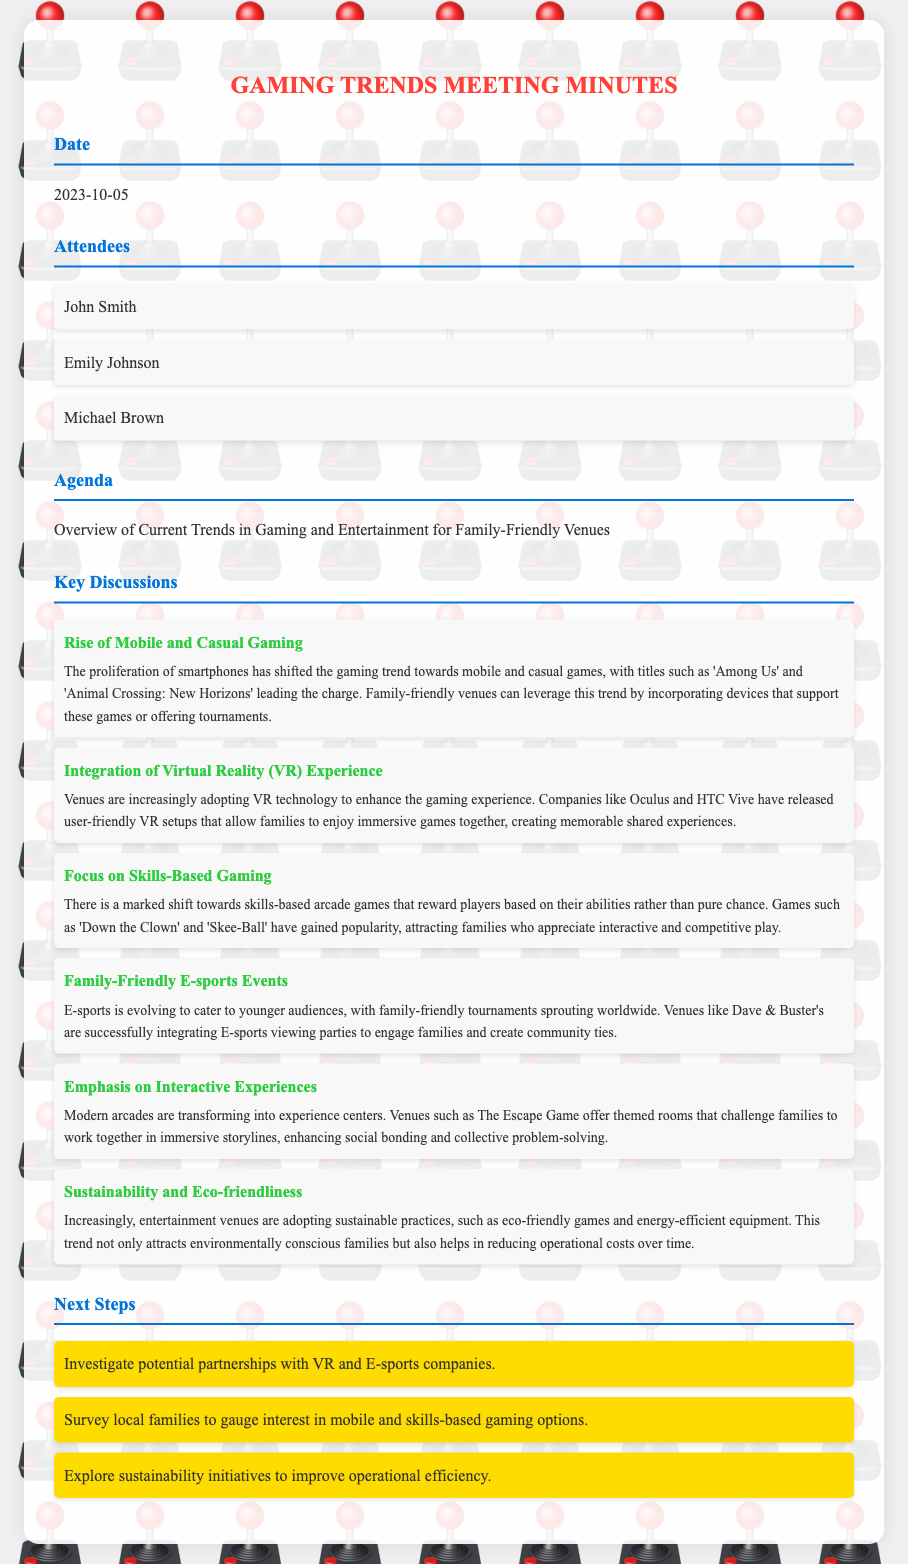What is the date of the meeting? The date of the meeting is specified under the Date section in the document.
Answer: 2023-10-05 Who is one of the attendees? Attendees are listed in the corresponding section, providing names of individuals present at the meeting.
Answer: John Smith What is the main topic discussed in the agenda? The agenda section outlines the primary focus of the meeting, which is specified in a single line.
Answer: Overview of Current Trends in Gaming and Entertainment for Family-Friendly Venues Which game is mentioned as an example of casual gaming? The key discussions provide specific examples relevant to the topics, including casual games.
Answer: Among Us What is one of the next steps outlined in the meeting? The next steps section lists actionable items that were discussed during the meeting for further follow-up.
Answer: Investigate potential partnerships with VR and E-sports companies How does the document categorize the shift towards skills-based gaming? The document details the developments in gaming trends, including distinctions between game types.
Answer: Skills-Based Gaming What is the emphasis of modern arcades according to the document? The details in the key discussions outline the evolving focus of modern arcade experiences.
Answer: Interactive Experiences How are family-friendly e-sports events described? The document describes the nature of e-sports events in relation to familial engagement and community aspects.
Answer: E-sports is evolving to cater to younger audiences 